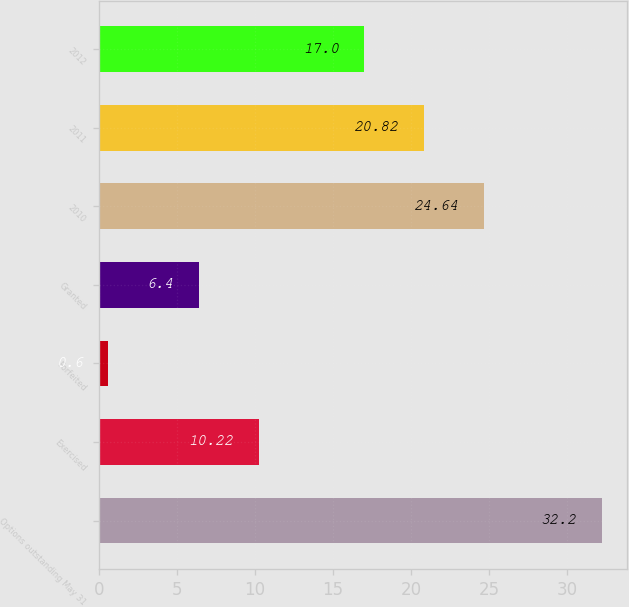Convert chart to OTSL. <chart><loc_0><loc_0><loc_500><loc_500><bar_chart><fcel>Options outstanding May 31<fcel>Exercised<fcel>Forfeited<fcel>Granted<fcel>2010<fcel>2011<fcel>2012<nl><fcel>32.2<fcel>10.22<fcel>0.6<fcel>6.4<fcel>24.64<fcel>20.82<fcel>17<nl></chart> 